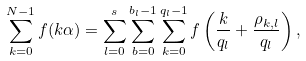Convert formula to latex. <formula><loc_0><loc_0><loc_500><loc_500>\sum _ { k = 0 } ^ { N - 1 } f ( k \alpha ) = \sum _ { l = 0 } ^ { s } \sum _ { b = 0 } ^ { b _ { l } - 1 } \sum _ { k = 0 } ^ { q _ { l } - 1 } f \left ( \frac { k } { q _ { l } } + \frac { \rho _ { k , l } } { q _ { l } } \right ) ,</formula> 